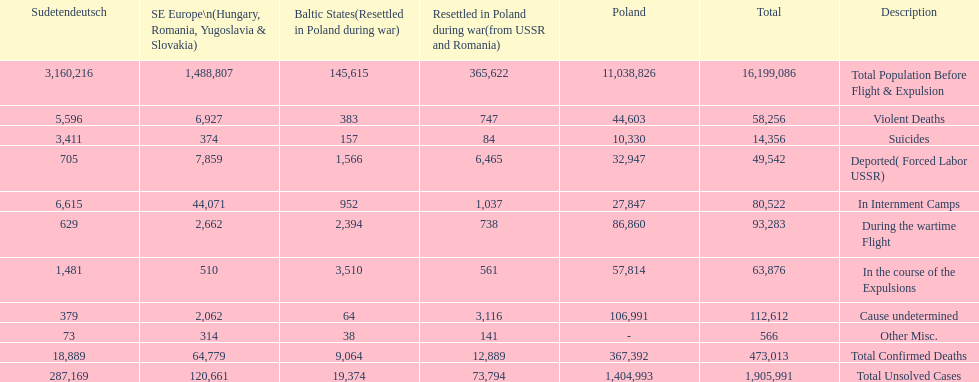What is the total of deaths in internment camps and during the wartime flight? 173,805. 